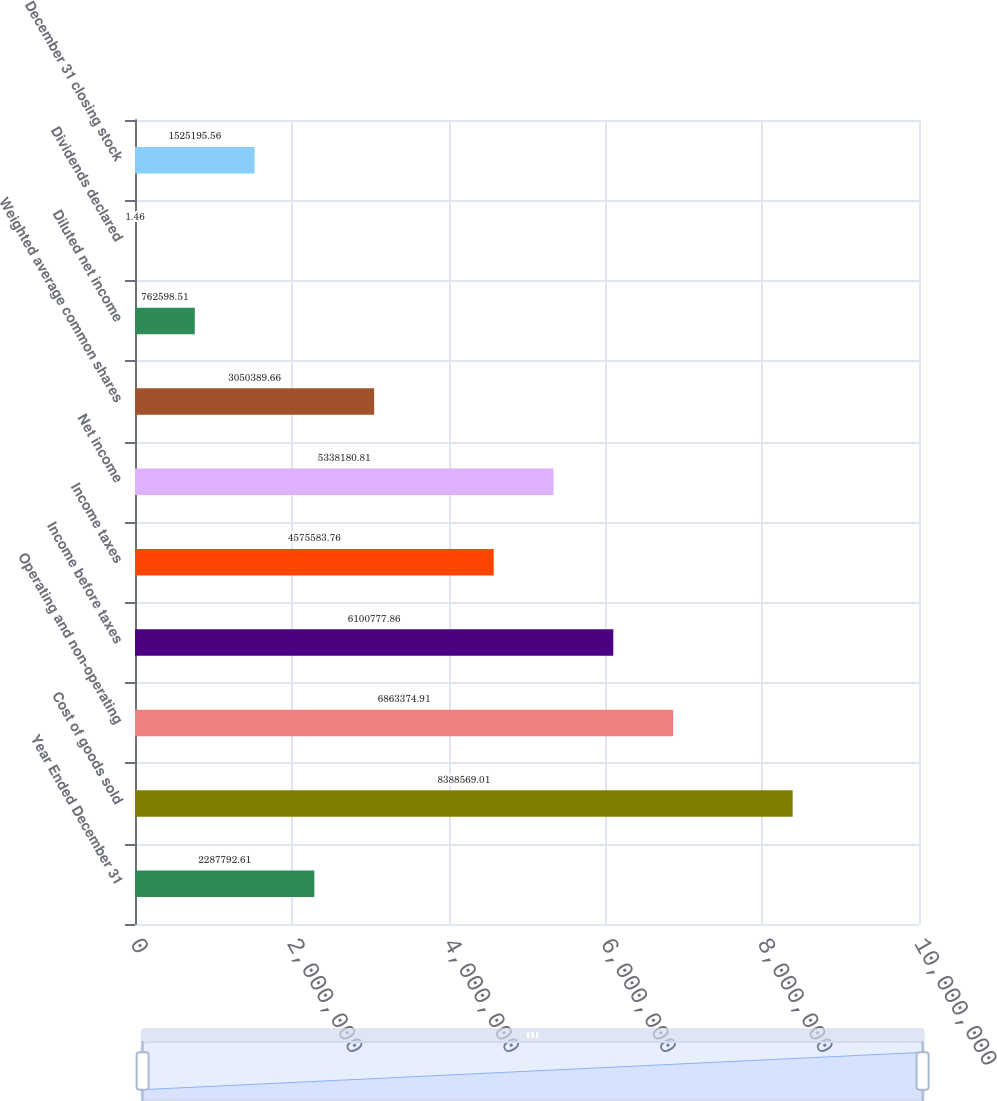Convert chart. <chart><loc_0><loc_0><loc_500><loc_500><bar_chart><fcel>Year Ended December 31<fcel>Cost of goods sold<fcel>Operating and non-operating<fcel>Income before taxes<fcel>Income taxes<fcel>Net income<fcel>Weighted average common shares<fcel>Diluted net income<fcel>Dividends declared<fcel>December 31 closing stock<nl><fcel>2.28779e+06<fcel>8.38857e+06<fcel>6.86337e+06<fcel>6.10078e+06<fcel>4.57558e+06<fcel>5.33818e+06<fcel>3.05039e+06<fcel>762599<fcel>1.46<fcel>1.5252e+06<nl></chart> 